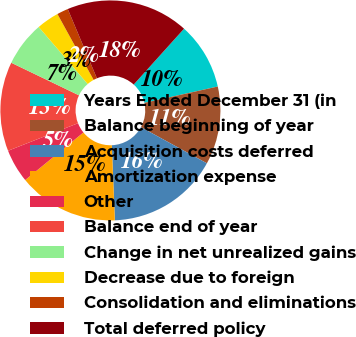<chart> <loc_0><loc_0><loc_500><loc_500><pie_chart><fcel>Years Ended December 31 (in<fcel>Balance beginning of year<fcel>Acquisition costs deferred<fcel>Amortization expense<fcel>Other<fcel>Balance end of year<fcel>Change in net unrealized gains<fcel>Decrease due to foreign<fcel>Consolidation and eliminations<fcel>Total deferred policy<nl><fcel>9.84%<fcel>11.47%<fcel>16.38%<fcel>14.74%<fcel>4.93%<fcel>13.11%<fcel>6.57%<fcel>3.3%<fcel>1.66%<fcel>18.01%<nl></chart> 